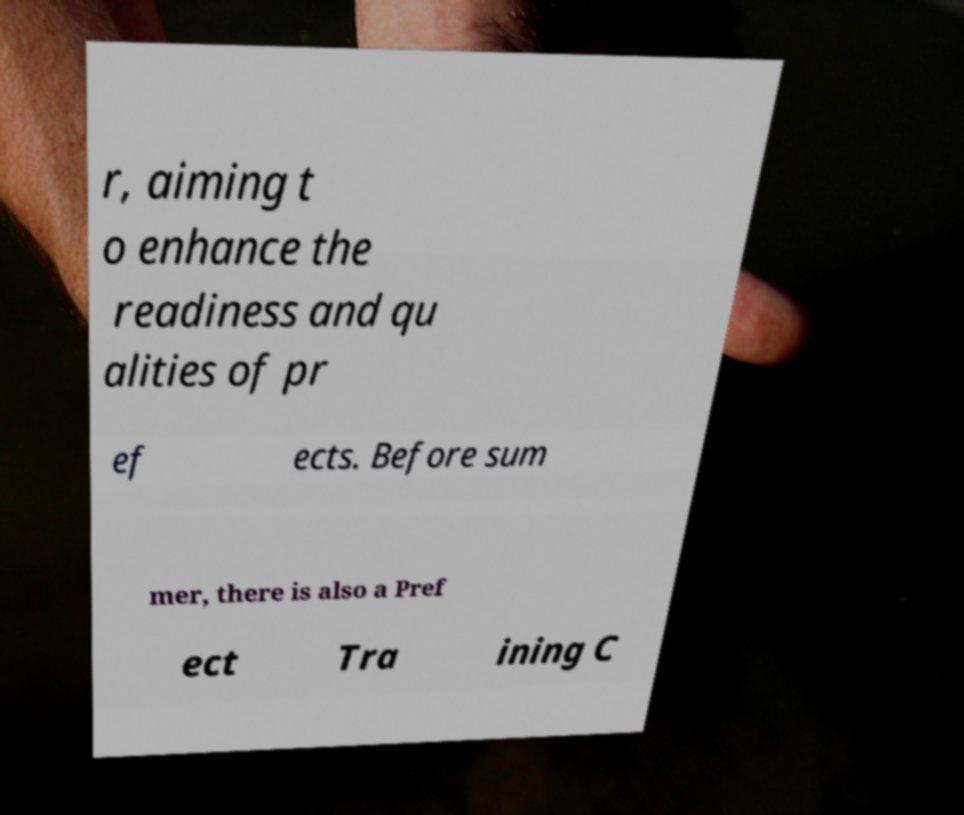I need the written content from this picture converted into text. Can you do that? r, aiming t o enhance the readiness and qu alities of pr ef ects. Before sum mer, there is also a Pref ect Tra ining C 